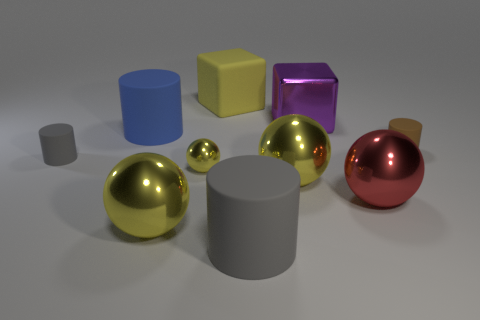Subtract all yellow spheres. How many were subtracted if there are1yellow spheres left? 2 Subtract all large red spheres. How many spheres are left? 3 Subtract all yellow balls. How many balls are left? 1 Subtract all spheres. How many objects are left? 6 Subtract 2 cubes. How many cubes are left? 0 Subtract all purple cylinders. How many yellow spheres are left? 3 Add 6 small yellow metal balls. How many small yellow metal balls are left? 7 Add 2 rubber things. How many rubber things exist? 7 Subtract 0 purple cylinders. How many objects are left? 10 Subtract all yellow balls. Subtract all brown cylinders. How many balls are left? 1 